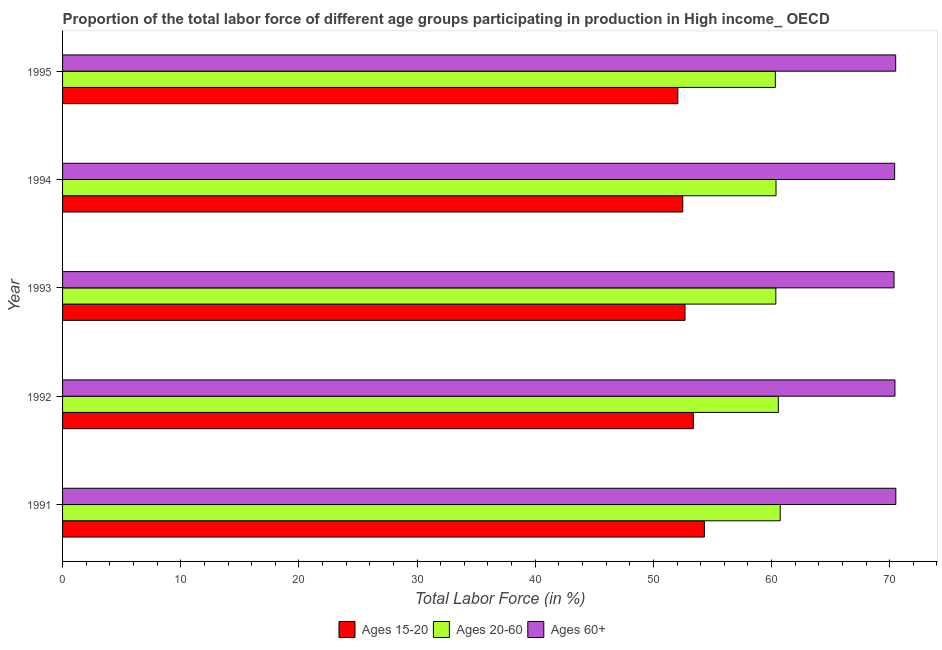How many different coloured bars are there?
Ensure brevity in your answer.  3. How many groups of bars are there?
Provide a short and direct response. 5. Are the number of bars per tick equal to the number of legend labels?
Provide a succinct answer. Yes. Are the number of bars on each tick of the Y-axis equal?
Make the answer very short. Yes. What is the label of the 1st group of bars from the top?
Your answer should be compact. 1995. What is the percentage of labor force above age 60 in 1991?
Provide a succinct answer. 70.52. Across all years, what is the maximum percentage of labor force within the age group 15-20?
Offer a very short reply. 54.32. Across all years, what is the minimum percentage of labor force within the age group 20-60?
Offer a very short reply. 60.32. In which year was the percentage of labor force above age 60 maximum?
Your answer should be very brief. 1991. What is the total percentage of labor force within the age group 20-60 in the graph?
Your answer should be compact. 302.37. What is the difference between the percentage of labor force within the age group 15-20 in 1993 and that in 1995?
Make the answer very short. 0.6. What is the difference between the percentage of labor force within the age group 20-60 in 1992 and the percentage of labor force within the age group 15-20 in 1993?
Provide a succinct answer. 7.9. What is the average percentage of labor force above age 60 per year?
Offer a very short reply. 70.45. In the year 1992, what is the difference between the percentage of labor force within the age group 15-20 and percentage of labor force within the age group 20-60?
Give a very brief answer. -7.2. In how many years, is the percentage of labor force within the age group 20-60 greater than 62 %?
Keep it short and to the point. 0. What is the difference between the highest and the second highest percentage of labor force within the age group 20-60?
Your answer should be very brief. 0.16. What is the difference between the highest and the lowest percentage of labor force above age 60?
Your response must be concise. 0.15. What does the 1st bar from the top in 1992 represents?
Provide a short and direct response. Ages 60+. What does the 3rd bar from the bottom in 1992 represents?
Make the answer very short. Ages 60+. Is it the case that in every year, the sum of the percentage of labor force within the age group 15-20 and percentage of labor force within the age group 20-60 is greater than the percentage of labor force above age 60?
Offer a terse response. Yes. How many bars are there?
Your answer should be very brief. 15. Are all the bars in the graph horizontal?
Keep it short and to the point. Yes. Are the values on the major ticks of X-axis written in scientific E-notation?
Keep it short and to the point. No. Does the graph contain any zero values?
Your answer should be compact. No. Does the graph contain grids?
Ensure brevity in your answer.  No. How many legend labels are there?
Offer a very short reply. 3. How are the legend labels stacked?
Provide a succinct answer. Horizontal. What is the title of the graph?
Keep it short and to the point. Proportion of the total labor force of different age groups participating in production in High income_ OECD. Does "Secondary" appear as one of the legend labels in the graph?
Your answer should be compact. No. What is the Total Labor Force (in %) in Ages 15-20 in 1991?
Provide a succinct answer. 54.32. What is the Total Labor Force (in %) of Ages 20-60 in 1991?
Make the answer very short. 60.73. What is the Total Labor Force (in %) of Ages 60+ in 1991?
Make the answer very short. 70.52. What is the Total Labor Force (in %) of Ages 15-20 in 1992?
Keep it short and to the point. 53.38. What is the Total Labor Force (in %) of Ages 20-60 in 1992?
Ensure brevity in your answer.  60.58. What is the Total Labor Force (in %) of Ages 60+ in 1992?
Make the answer very short. 70.44. What is the Total Labor Force (in %) in Ages 15-20 in 1993?
Make the answer very short. 52.68. What is the Total Labor Force (in %) of Ages 20-60 in 1993?
Provide a short and direct response. 60.36. What is the Total Labor Force (in %) in Ages 60+ in 1993?
Offer a very short reply. 70.37. What is the Total Labor Force (in %) in Ages 15-20 in 1994?
Your response must be concise. 52.49. What is the Total Labor Force (in %) of Ages 20-60 in 1994?
Provide a succinct answer. 60.38. What is the Total Labor Force (in %) in Ages 60+ in 1994?
Your answer should be very brief. 70.42. What is the Total Labor Force (in %) in Ages 15-20 in 1995?
Offer a terse response. 52.07. What is the Total Labor Force (in %) of Ages 20-60 in 1995?
Your response must be concise. 60.32. What is the Total Labor Force (in %) in Ages 60+ in 1995?
Keep it short and to the point. 70.51. Across all years, what is the maximum Total Labor Force (in %) of Ages 15-20?
Keep it short and to the point. 54.32. Across all years, what is the maximum Total Labor Force (in %) in Ages 20-60?
Keep it short and to the point. 60.73. Across all years, what is the maximum Total Labor Force (in %) in Ages 60+?
Your answer should be very brief. 70.52. Across all years, what is the minimum Total Labor Force (in %) of Ages 15-20?
Keep it short and to the point. 52.07. Across all years, what is the minimum Total Labor Force (in %) of Ages 20-60?
Keep it short and to the point. 60.32. Across all years, what is the minimum Total Labor Force (in %) in Ages 60+?
Provide a succinct answer. 70.37. What is the total Total Labor Force (in %) of Ages 15-20 in the graph?
Ensure brevity in your answer.  264.93. What is the total Total Labor Force (in %) in Ages 20-60 in the graph?
Offer a terse response. 302.37. What is the total Total Labor Force (in %) of Ages 60+ in the graph?
Make the answer very short. 352.26. What is the difference between the Total Labor Force (in %) of Ages 15-20 in 1991 and that in 1992?
Give a very brief answer. 0.94. What is the difference between the Total Labor Force (in %) of Ages 20-60 in 1991 and that in 1992?
Give a very brief answer. 0.16. What is the difference between the Total Labor Force (in %) of Ages 60+ in 1991 and that in 1992?
Provide a short and direct response. 0.07. What is the difference between the Total Labor Force (in %) in Ages 15-20 in 1991 and that in 1993?
Your answer should be very brief. 1.64. What is the difference between the Total Labor Force (in %) of Ages 20-60 in 1991 and that in 1993?
Make the answer very short. 0.37. What is the difference between the Total Labor Force (in %) in Ages 60+ in 1991 and that in 1993?
Keep it short and to the point. 0.15. What is the difference between the Total Labor Force (in %) in Ages 15-20 in 1991 and that in 1994?
Offer a very short reply. 1.83. What is the difference between the Total Labor Force (in %) of Ages 20-60 in 1991 and that in 1994?
Keep it short and to the point. 0.36. What is the difference between the Total Labor Force (in %) in Ages 60+ in 1991 and that in 1994?
Your response must be concise. 0.1. What is the difference between the Total Labor Force (in %) of Ages 15-20 in 1991 and that in 1995?
Ensure brevity in your answer.  2.25. What is the difference between the Total Labor Force (in %) in Ages 20-60 in 1991 and that in 1995?
Make the answer very short. 0.41. What is the difference between the Total Labor Force (in %) of Ages 60+ in 1991 and that in 1995?
Offer a terse response. 0.01. What is the difference between the Total Labor Force (in %) of Ages 15-20 in 1992 and that in 1993?
Your answer should be compact. 0.7. What is the difference between the Total Labor Force (in %) of Ages 20-60 in 1992 and that in 1993?
Your response must be concise. 0.21. What is the difference between the Total Labor Force (in %) in Ages 60+ in 1992 and that in 1993?
Offer a terse response. 0.08. What is the difference between the Total Labor Force (in %) of Ages 15-20 in 1992 and that in 1994?
Give a very brief answer. 0.89. What is the difference between the Total Labor Force (in %) in Ages 20-60 in 1992 and that in 1994?
Offer a terse response. 0.2. What is the difference between the Total Labor Force (in %) of Ages 60+ in 1992 and that in 1994?
Provide a short and direct response. 0.03. What is the difference between the Total Labor Force (in %) of Ages 15-20 in 1992 and that in 1995?
Offer a terse response. 1.31. What is the difference between the Total Labor Force (in %) of Ages 20-60 in 1992 and that in 1995?
Offer a very short reply. 0.26. What is the difference between the Total Labor Force (in %) of Ages 60+ in 1992 and that in 1995?
Keep it short and to the point. -0.06. What is the difference between the Total Labor Force (in %) of Ages 15-20 in 1993 and that in 1994?
Your answer should be very brief. 0.19. What is the difference between the Total Labor Force (in %) of Ages 20-60 in 1993 and that in 1994?
Your response must be concise. -0.02. What is the difference between the Total Labor Force (in %) of Ages 60+ in 1993 and that in 1994?
Give a very brief answer. -0.05. What is the difference between the Total Labor Force (in %) in Ages 15-20 in 1993 and that in 1995?
Offer a very short reply. 0.61. What is the difference between the Total Labor Force (in %) in Ages 20-60 in 1993 and that in 1995?
Your response must be concise. 0.04. What is the difference between the Total Labor Force (in %) in Ages 60+ in 1993 and that in 1995?
Provide a succinct answer. -0.14. What is the difference between the Total Labor Force (in %) in Ages 15-20 in 1994 and that in 1995?
Ensure brevity in your answer.  0.42. What is the difference between the Total Labor Force (in %) of Ages 20-60 in 1994 and that in 1995?
Offer a very short reply. 0.06. What is the difference between the Total Labor Force (in %) in Ages 60+ in 1994 and that in 1995?
Your response must be concise. -0.09. What is the difference between the Total Labor Force (in %) in Ages 15-20 in 1991 and the Total Labor Force (in %) in Ages 20-60 in 1992?
Your response must be concise. -6.26. What is the difference between the Total Labor Force (in %) in Ages 15-20 in 1991 and the Total Labor Force (in %) in Ages 60+ in 1992?
Give a very brief answer. -16.13. What is the difference between the Total Labor Force (in %) in Ages 20-60 in 1991 and the Total Labor Force (in %) in Ages 60+ in 1992?
Give a very brief answer. -9.71. What is the difference between the Total Labor Force (in %) of Ages 15-20 in 1991 and the Total Labor Force (in %) of Ages 20-60 in 1993?
Your answer should be compact. -6.05. What is the difference between the Total Labor Force (in %) of Ages 15-20 in 1991 and the Total Labor Force (in %) of Ages 60+ in 1993?
Provide a short and direct response. -16.05. What is the difference between the Total Labor Force (in %) of Ages 20-60 in 1991 and the Total Labor Force (in %) of Ages 60+ in 1993?
Provide a succinct answer. -9.63. What is the difference between the Total Labor Force (in %) of Ages 15-20 in 1991 and the Total Labor Force (in %) of Ages 20-60 in 1994?
Provide a short and direct response. -6.06. What is the difference between the Total Labor Force (in %) of Ages 15-20 in 1991 and the Total Labor Force (in %) of Ages 60+ in 1994?
Give a very brief answer. -16.1. What is the difference between the Total Labor Force (in %) in Ages 20-60 in 1991 and the Total Labor Force (in %) in Ages 60+ in 1994?
Provide a short and direct response. -9.68. What is the difference between the Total Labor Force (in %) of Ages 15-20 in 1991 and the Total Labor Force (in %) of Ages 20-60 in 1995?
Ensure brevity in your answer.  -6.01. What is the difference between the Total Labor Force (in %) of Ages 15-20 in 1991 and the Total Labor Force (in %) of Ages 60+ in 1995?
Provide a short and direct response. -16.19. What is the difference between the Total Labor Force (in %) in Ages 20-60 in 1991 and the Total Labor Force (in %) in Ages 60+ in 1995?
Offer a terse response. -9.77. What is the difference between the Total Labor Force (in %) of Ages 15-20 in 1992 and the Total Labor Force (in %) of Ages 20-60 in 1993?
Offer a terse response. -6.98. What is the difference between the Total Labor Force (in %) in Ages 15-20 in 1992 and the Total Labor Force (in %) in Ages 60+ in 1993?
Make the answer very short. -16.99. What is the difference between the Total Labor Force (in %) of Ages 20-60 in 1992 and the Total Labor Force (in %) of Ages 60+ in 1993?
Ensure brevity in your answer.  -9.79. What is the difference between the Total Labor Force (in %) in Ages 15-20 in 1992 and the Total Labor Force (in %) in Ages 20-60 in 1994?
Your answer should be compact. -7. What is the difference between the Total Labor Force (in %) in Ages 15-20 in 1992 and the Total Labor Force (in %) in Ages 60+ in 1994?
Your response must be concise. -17.04. What is the difference between the Total Labor Force (in %) of Ages 20-60 in 1992 and the Total Labor Force (in %) of Ages 60+ in 1994?
Provide a succinct answer. -9.84. What is the difference between the Total Labor Force (in %) of Ages 15-20 in 1992 and the Total Labor Force (in %) of Ages 20-60 in 1995?
Give a very brief answer. -6.94. What is the difference between the Total Labor Force (in %) in Ages 15-20 in 1992 and the Total Labor Force (in %) in Ages 60+ in 1995?
Provide a succinct answer. -17.13. What is the difference between the Total Labor Force (in %) in Ages 20-60 in 1992 and the Total Labor Force (in %) in Ages 60+ in 1995?
Ensure brevity in your answer.  -9.93. What is the difference between the Total Labor Force (in %) in Ages 15-20 in 1993 and the Total Labor Force (in %) in Ages 20-60 in 1994?
Give a very brief answer. -7.7. What is the difference between the Total Labor Force (in %) of Ages 15-20 in 1993 and the Total Labor Force (in %) of Ages 60+ in 1994?
Your answer should be very brief. -17.74. What is the difference between the Total Labor Force (in %) in Ages 20-60 in 1993 and the Total Labor Force (in %) in Ages 60+ in 1994?
Your response must be concise. -10.06. What is the difference between the Total Labor Force (in %) in Ages 15-20 in 1993 and the Total Labor Force (in %) in Ages 20-60 in 1995?
Provide a succinct answer. -7.65. What is the difference between the Total Labor Force (in %) in Ages 15-20 in 1993 and the Total Labor Force (in %) in Ages 60+ in 1995?
Keep it short and to the point. -17.83. What is the difference between the Total Labor Force (in %) of Ages 20-60 in 1993 and the Total Labor Force (in %) of Ages 60+ in 1995?
Your response must be concise. -10.14. What is the difference between the Total Labor Force (in %) of Ages 15-20 in 1994 and the Total Labor Force (in %) of Ages 20-60 in 1995?
Make the answer very short. -7.83. What is the difference between the Total Labor Force (in %) of Ages 15-20 in 1994 and the Total Labor Force (in %) of Ages 60+ in 1995?
Ensure brevity in your answer.  -18.02. What is the difference between the Total Labor Force (in %) in Ages 20-60 in 1994 and the Total Labor Force (in %) in Ages 60+ in 1995?
Keep it short and to the point. -10.13. What is the average Total Labor Force (in %) in Ages 15-20 per year?
Ensure brevity in your answer.  52.99. What is the average Total Labor Force (in %) of Ages 20-60 per year?
Make the answer very short. 60.47. What is the average Total Labor Force (in %) in Ages 60+ per year?
Make the answer very short. 70.45. In the year 1991, what is the difference between the Total Labor Force (in %) in Ages 15-20 and Total Labor Force (in %) in Ages 20-60?
Give a very brief answer. -6.42. In the year 1991, what is the difference between the Total Labor Force (in %) in Ages 15-20 and Total Labor Force (in %) in Ages 60+?
Give a very brief answer. -16.2. In the year 1991, what is the difference between the Total Labor Force (in %) of Ages 20-60 and Total Labor Force (in %) of Ages 60+?
Give a very brief answer. -9.78. In the year 1992, what is the difference between the Total Labor Force (in %) of Ages 15-20 and Total Labor Force (in %) of Ages 20-60?
Ensure brevity in your answer.  -7.2. In the year 1992, what is the difference between the Total Labor Force (in %) in Ages 15-20 and Total Labor Force (in %) in Ages 60+?
Your answer should be compact. -17.07. In the year 1992, what is the difference between the Total Labor Force (in %) of Ages 20-60 and Total Labor Force (in %) of Ages 60+?
Keep it short and to the point. -9.87. In the year 1993, what is the difference between the Total Labor Force (in %) of Ages 15-20 and Total Labor Force (in %) of Ages 20-60?
Make the answer very short. -7.69. In the year 1993, what is the difference between the Total Labor Force (in %) in Ages 15-20 and Total Labor Force (in %) in Ages 60+?
Make the answer very short. -17.69. In the year 1993, what is the difference between the Total Labor Force (in %) in Ages 20-60 and Total Labor Force (in %) in Ages 60+?
Provide a short and direct response. -10.01. In the year 1994, what is the difference between the Total Labor Force (in %) in Ages 15-20 and Total Labor Force (in %) in Ages 20-60?
Offer a very short reply. -7.89. In the year 1994, what is the difference between the Total Labor Force (in %) in Ages 15-20 and Total Labor Force (in %) in Ages 60+?
Offer a terse response. -17.93. In the year 1994, what is the difference between the Total Labor Force (in %) of Ages 20-60 and Total Labor Force (in %) of Ages 60+?
Offer a terse response. -10.04. In the year 1995, what is the difference between the Total Labor Force (in %) in Ages 15-20 and Total Labor Force (in %) in Ages 20-60?
Give a very brief answer. -8.25. In the year 1995, what is the difference between the Total Labor Force (in %) in Ages 15-20 and Total Labor Force (in %) in Ages 60+?
Provide a short and direct response. -18.44. In the year 1995, what is the difference between the Total Labor Force (in %) of Ages 20-60 and Total Labor Force (in %) of Ages 60+?
Keep it short and to the point. -10.19. What is the ratio of the Total Labor Force (in %) in Ages 15-20 in 1991 to that in 1992?
Your answer should be compact. 1.02. What is the ratio of the Total Labor Force (in %) of Ages 15-20 in 1991 to that in 1993?
Your response must be concise. 1.03. What is the ratio of the Total Labor Force (in %) of Ages 15-20 in 1991 to that in 1994?
Offer a very short reply. 1.03. What is the ratio of the Total Labor Force (in %) in Ages 20-60 in 1991 to that in 1994?
Offer a very short reply. 1.01. What is the ratio of the Total Labor Force (in %) in Ages 60+ in 1991 to that in 1994?
Make the answer very short. 1. What is the ratio of the Total Labor Force (in %) in Ages 15-20 in 1991 to that in 1995?
Make the answer very short. 1.04. What is the ratio of the Total Labor Force (in %) of Ages 20-60 in 1991 to that in 1995?
Provide a short and direct response. 1.01. What is the ratio of the Total Labor Force (in %) in Ages 60+ in 1991 to that in 1995?
Your answer should be very brief. 1. What is the ratio of the Total Labor Force (in %) of Ages 15-20 in 1992 to that in 1993?
Make the answer very short. 1.01. What is the ratio of the Total Labor Force (in %) in Ages 60+ in 1992 to that in 1994?
Make the answer very short. 1. What is the ratio of the Total Labor Force (in %) in Ages 15-20 in 1992 to that in 1995?
Offer a very short reply. 1.03. What is the ratio of the Total Labor Force (in %) of Ages 60+ in 1992 to that in 1995?
Your answer should be compact. 1. What is the ratio of the Total Labor Force (in %) in Ages 15-20 in 1993 to that in 1995?
Give a very brief answer. 1.01. What is the difference between the highest and the second highest Total Labor Force (in %) of Ages 15-20?
Give a very brief answer. 0.94. What is the difference between the highest and the second highest Total Labor Force (in %) of Ages 20-60?
Keep it short and to the point. 0.16. What is the difference between the highest and the second highest Total Labor Force (in %) in Ages 60+?
Provide a short and direct response. 0.01. What is the difference between the highest and the lowest Total Labor Force (in %) of Ages 15-20?
Offer a very short reply. 2.25. What is the difference between the highest and the lowest Total Labor Force (in %) in Ages 20-60?
Offer a very short reply. 0.41. What is the difference between the highest and the lowest Total Labor Force (in %) of Ages 60+?
Offer a terse response. 0.15. 